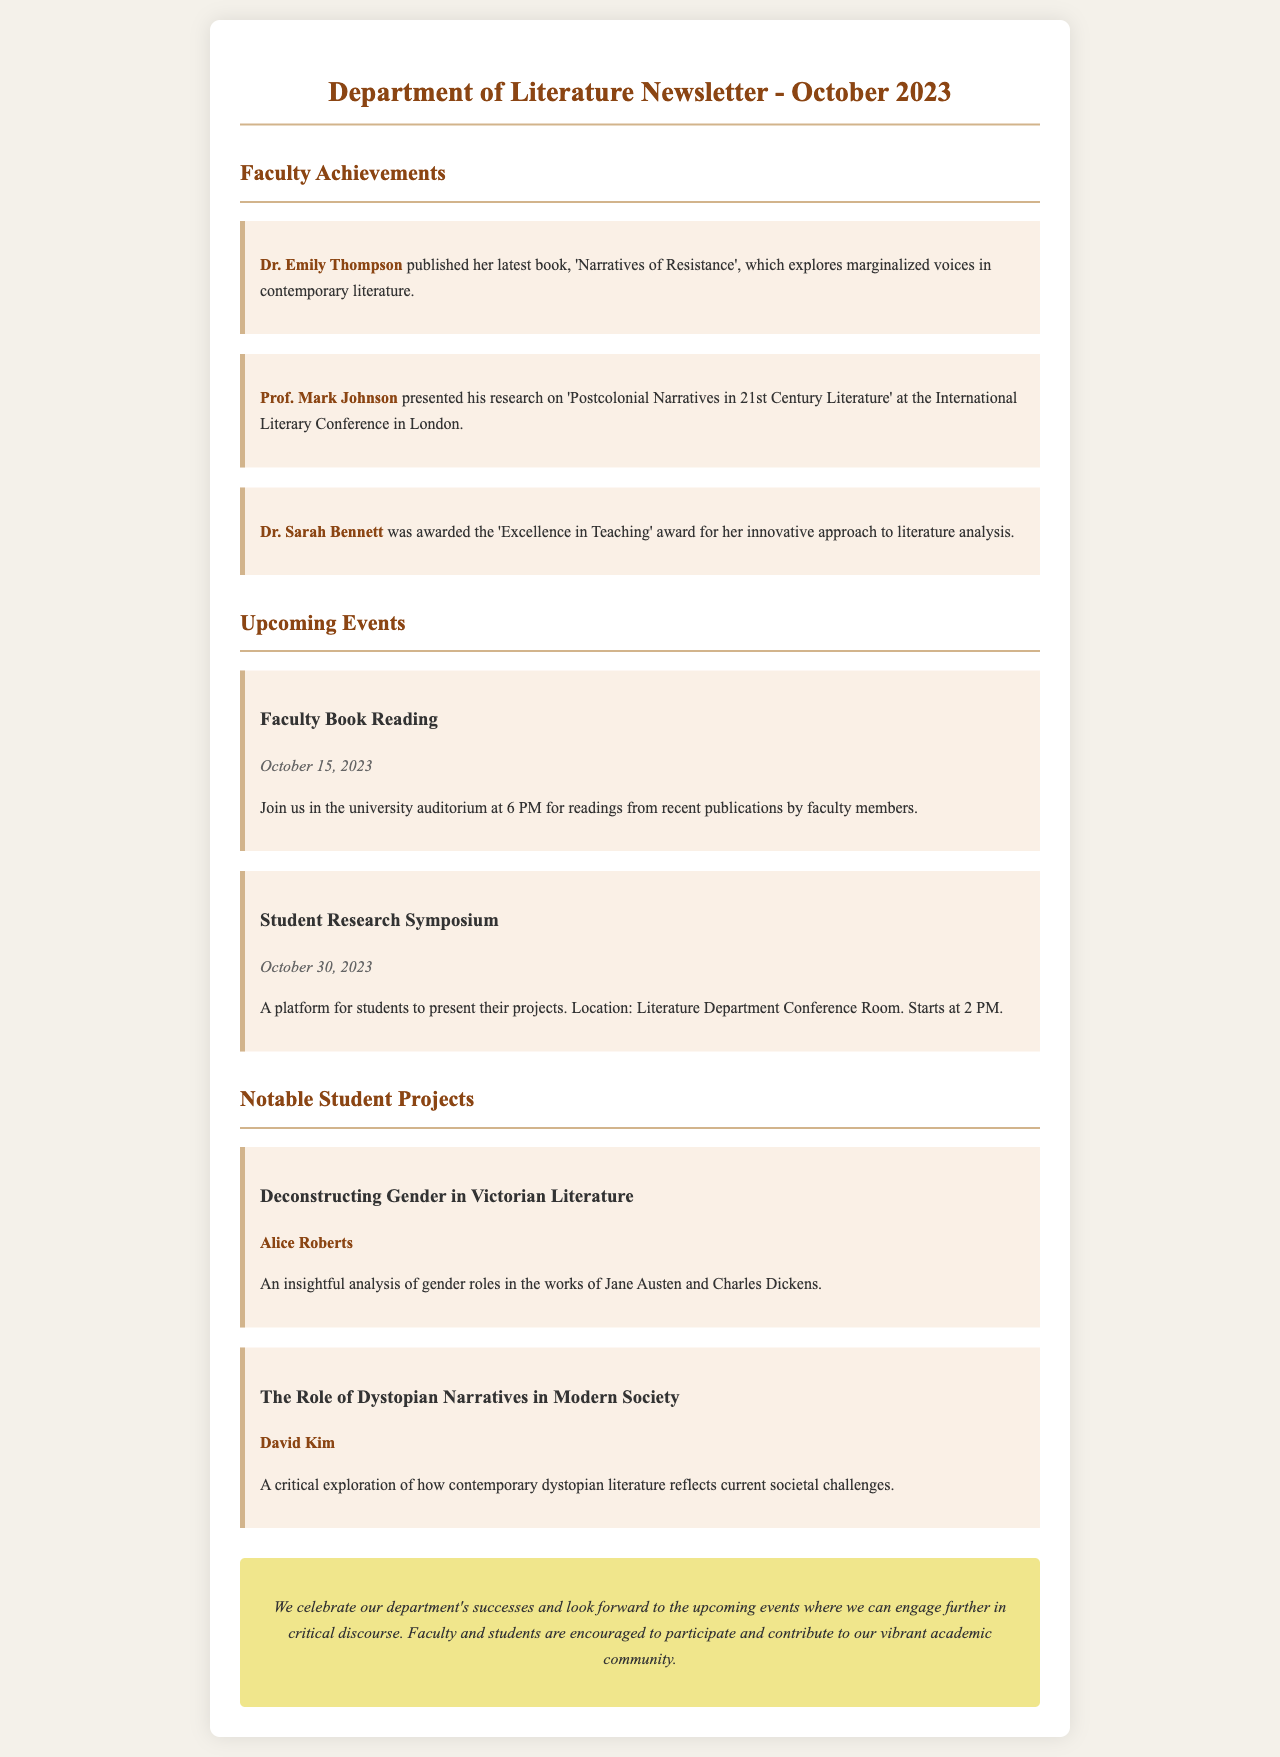What is the title of Dr. Emily Thompson's latest book? The document mentions that Dr. Emily Thompson published a book titled 'Narratives of Resistance'.
Answer: 'Narratives of Resistance' Who presented research on postcolonial narratives? The document states that Prof. Mark Johnson presented his research on 'Postcolonial Narratives in 21st Century Literature' at a conference.
Answer: Prof. Mark Johnson When is the Student Research Symposium scheduled? The document indicates that the Student Research Symposium is scheduled for October 30, 2023.
Answer: October 30, 2023 What is the name of the student who analyzed gender roles in Victorian literature? According to the document, the student who conducted the analysis is Alice Roberts.
Answer: Alice Roberts What is the location for the Faculty Book Reading event? The document specifies that the Faculty Book Reading will take place in the university auditorium.
Answer: university auditorium How does Dr. Sarah Bennett's achievement relate to teaching? The document highlights that Dr. Sarah Bennett was awarded for her innovative approach to literature analysis, reflecting her excellence in teaching.
Answer: innovative approach to literature analysis What theme does David Kim explore in his project? The document discusses that David Kim's project critically explores dystopian narratives in modern society.
Answer: dystopian narratives in modern society What is the purpose of the upcoming Student Research Symposium? The document explains that the aim of the symposium is to provide a platform for students to present their projects.
Answer: platform for students to present their projects How often is the department newsletter published? The document refers to this as the "October 2023" newsletter, indicating it is a monthly edition.
Answer: monthly 